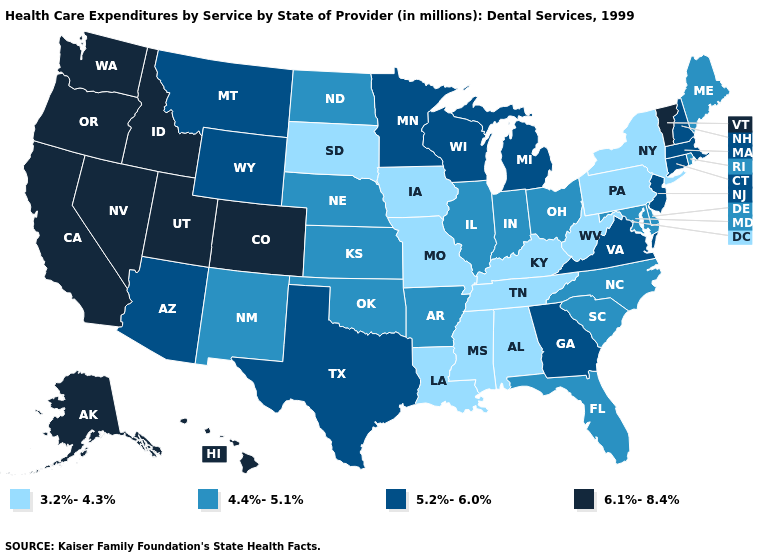Name the states that have a value in the range 4.4%-5.1%?
Keep it brief. Arkansas, Delaware, Florida, Illinois, Indiana, Kansas, Maine, Maryland, Nebraska, New Mexico, North Carolina, North Dakota, Ohio, Oklahoma, Rhode Island, South Carolina. What is the lowest value in states that border North Dakota?
Concise answer only. 3.2%-4.3%. Does Iowa have the highest value in the MidWest?
Keep it brief. No. What is the lowest value in states that border Mississippi?
Concise answer only. 3.2%-4.3%. Does New Mexico have a higher value than Oregon?
Concise answer only. No. Does Utah have the highest value in the USA?
Short answer required. Yes. Name the states that have a value in the range 4.4%-5.1%?
Keep it brief. Arkansas, Delaware, Florida, Illinois, Indiana, Kansas, Maine, Maryland, Nebraska, New Mexico, North Carolina, North Dakota, Ohio, Oklahoma, Rhode Island, South Carolina. Which states have the lowest value in the West?
Write a very short answer. New Mexico. What is the value of Montana?
Quick response, please. 5.2%-6.0%. Among the states that border Kansas , which have the lowest value?
Concise answer only. Missouri. Name the states that have a value in the range 5.2%-6.0%?
Quick response, please. Arizona, Connecticut, Georgia, Massachusetts, Michigan, Minnesota, Montana, New Hampshire, New Jersey, Texas, Virginia, Wisconsin, Wyoming. Among the states that border West Virginia , does Maryland have the lowest value?
Quick response, please. No. Is the legend a continuous bar?
Answer briefly. No. Name the states that have a value in the range 6.1%-8.4%?
Write a very short answer. Alaska, California, Colorado, Hawaii, Idaho, Nevada, Oregon, Utah, Vermont, Washington. Name the states that have a value in the range 4.4%-5.1%?
Concise answer only. Arkansas, Delaware, Florida, Illinois, Indiana, Kansas, Maine, Maryland, Nebraska, New Mexico, North Carolina, North Dakota, Ohio, Oklahoma, Rhode Island, South Carolina. 